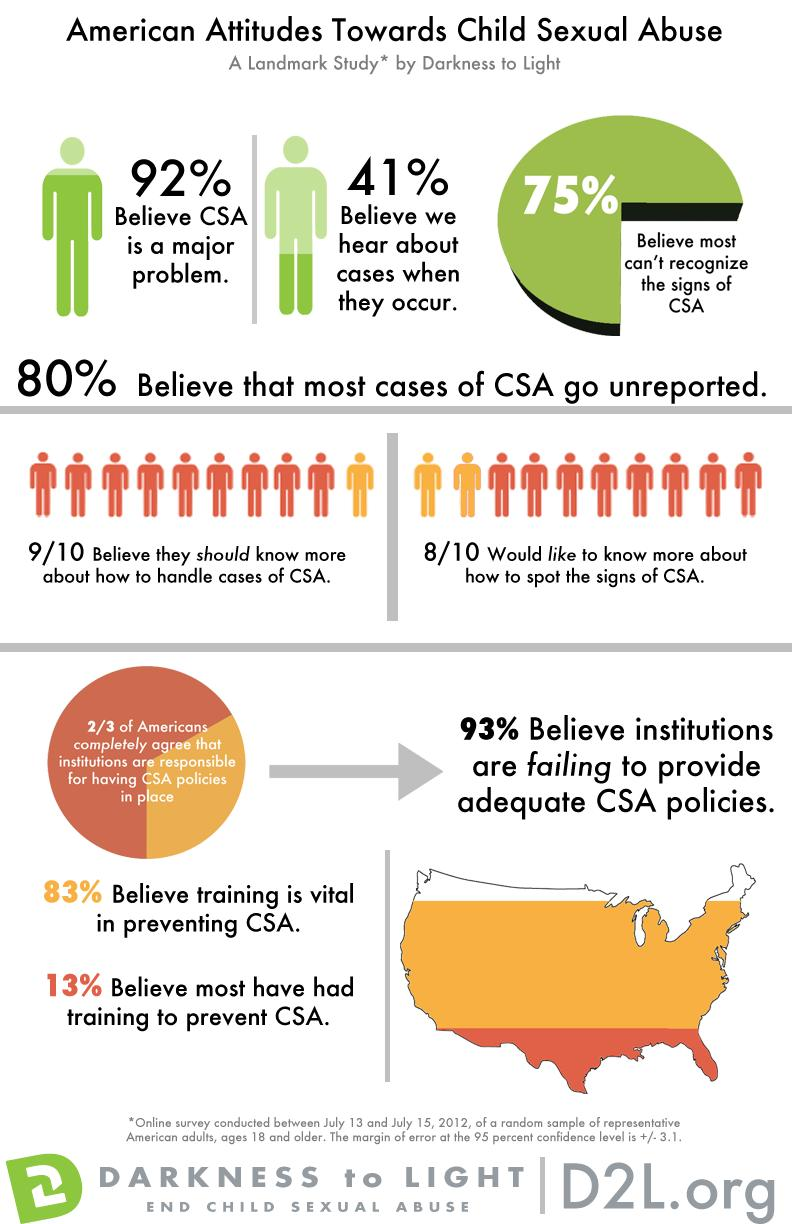Indicate a few pertinent items in this graphic. According to a recent survey, an overwhelming 92% of people believe that child sexual abuse is a major issue that requires urgent attention and action. 